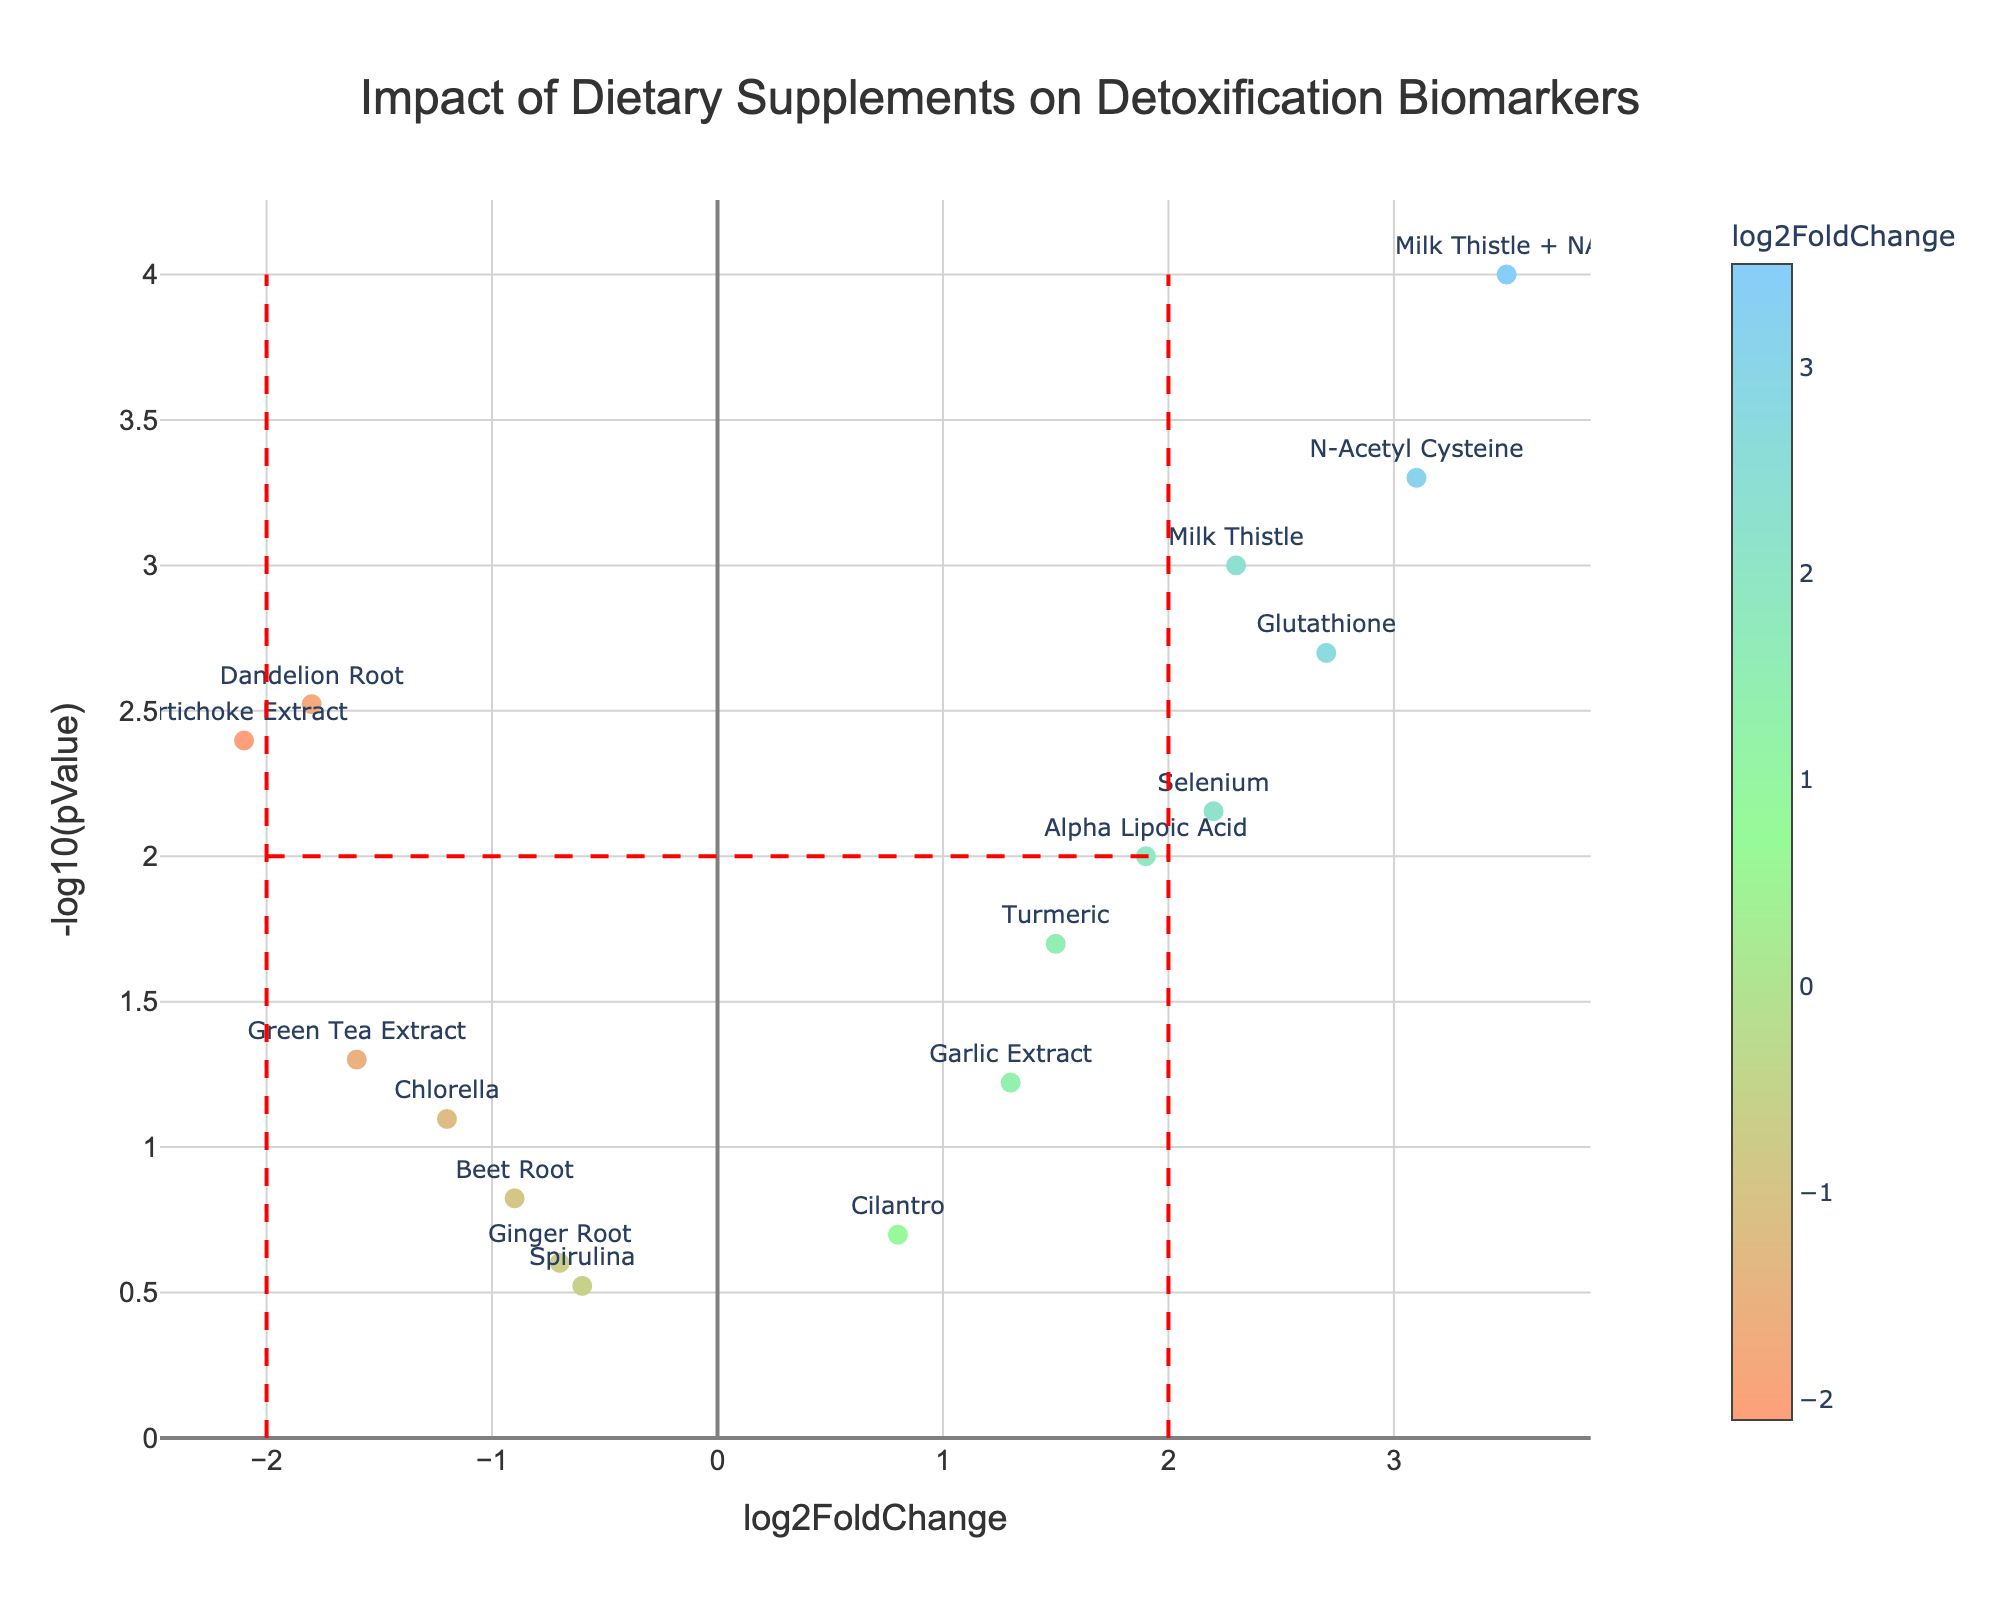What is the title of the figure? The title is displayed prominently at the top of the figure. It reads "Impact of Dietary Supplements on Detoxification Biomarkers."
Answer: Impact of Dietary Supplements on Detoxification Biomarkers How many supplements have a log2FoldChange greater than 2? To find this, count the markers plotted on the x-axis with values greater than 2. The supplements are Milk Thistle, NAC, Glutathione, and Milk Thistle + NAC, totaling four.
Answer: 4 Which supplement has the highest log2FoldChange? Look for the marker farthest to the right on the x-axis. The supplement with the highest log2FoldChange (3.5) is Milk Thistle + NAC.
Answer: Milk Thistle + NAC How many supplements have a pValue less than 0.01? Convert the -log10(pValue) to pValue: -log10(0.01) = 2. Count the markers above 2 on the y-axis. There are five: Milk Thistle, NAC, Glutathione, Milk Thistle + NAC, and Artichoke Extract.
Answer: 5 Which supplement is closest to having a log2FoldChange of 0 but significant levels of -log10(pValue)? Find the marker closest to x=0 but high on the y-axis. Cilantro is closest to this point.
Answer: Cilantro Which supplement has the least significant pValue? The least significant pValue corresponds to the lowest value on the y-axis (-log10(pValue)). This marker belongs to Spirulina.
Answer: Spirulina What are the coordinates of the supplement Dandelion Root on the plot? Locate Dandelion Root in the data and note its coordinates (log2FoldChange, -log10(pValue)). The values are (-1.8, 2.5228787).
Answer: (-1.8, 2.5228787) How many supplements have negative log2FoldChange values? Count the markers to the left of the y-axis (x=0). There are six: Dandelion Root, Beet Root, Chlorella, Artichoke Extract, Green Tea Extract, and Ginger Root.
Answer: 6 Which supplement has the highest significance in terms of pValue? The highest -log10(pValue) indicates the most significant pValue. Locate the top-most marker on the y-axis. This is Milk Thistle + NAC.
Answer: Milk Thistle + NAC 